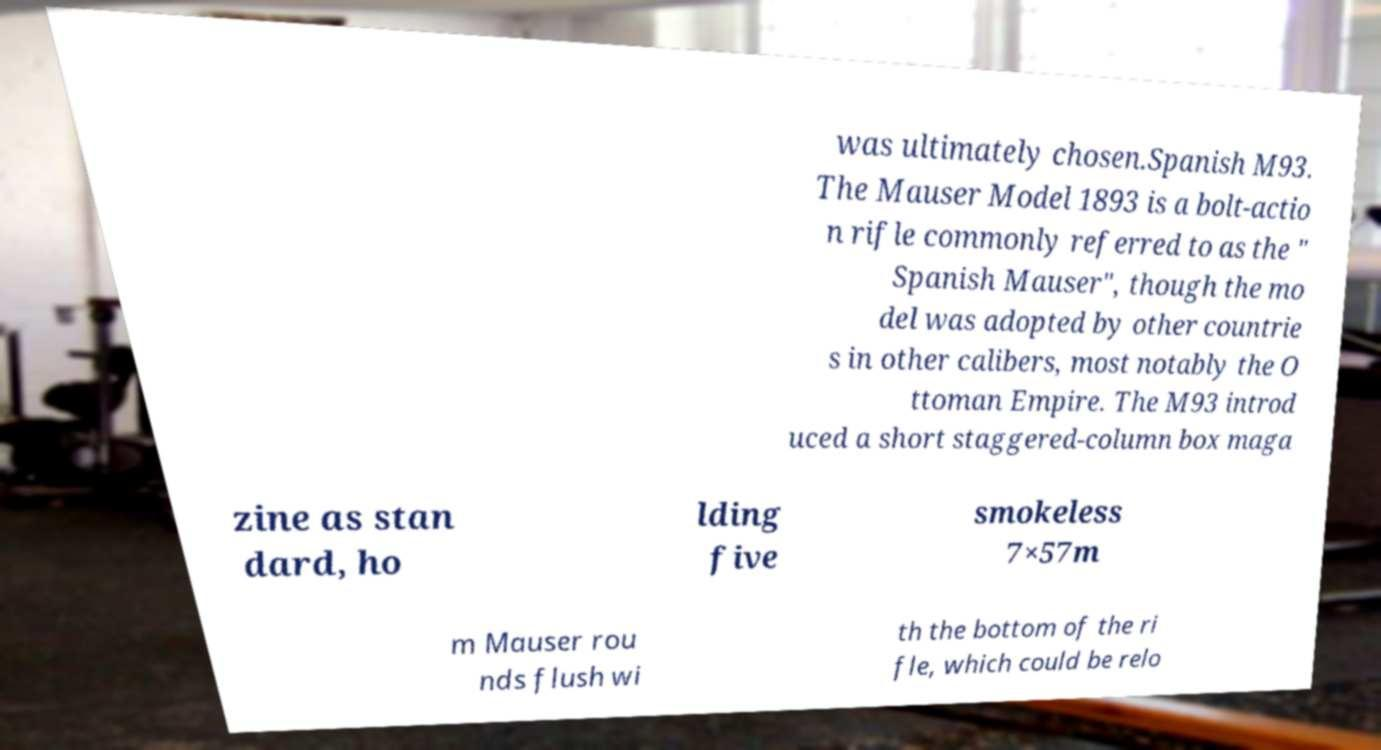For documentation purposes, I need the text within this image transcribed. Could you provide that? was ultimately chosen.Spanish M93. The Mauser Model 1893 is a bolt-actio n rifle commonly referred to as the " Spanish Mauser", though the mo del was adopted by other countrie s in other calibers, most notably the O ttoman Empire. The M93 introd uced a short staggered-column box maga zine as stan dard, ho lding five smokeless 7×57m m Mauser rou nds flush wi th the bottom of the ri fle, which could be relo 